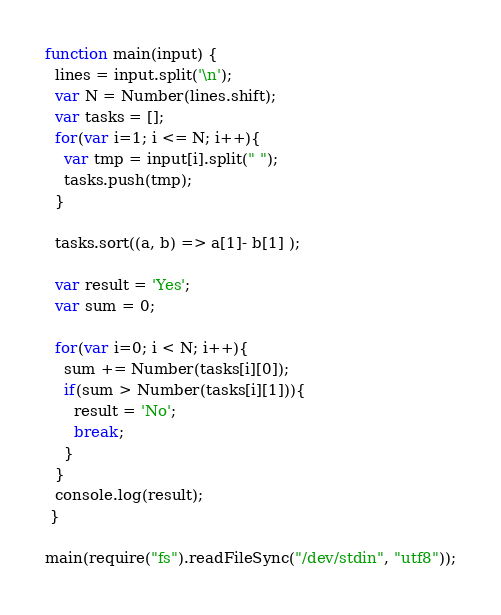<code> <loc_0><loc_0><loc_500><loc_500><_JavaScript_>function main(input) {
  lines = input.split('\n');
  var N = Number(lines.shift);
  var tasks = [];
  for(var i=1; i <= N; i++){
    var tmp = input[i].split(" ");
    tasks.push(tmp);
  }

  tasks.sort((a, b) => a[1]- b[1] );

  var result = 'Yes';
  var sum = 0;

  for(var i=0; i < N; i++){
    sum += Number(tasks[i][0]);
    if(sum > Number(tasks[i][1])){
      result = 'No';
      break;
    }
  }
  console.log(result);
 }

main(require("fs").readFileSync("/dev/stdin", "utf8"));
</code> 